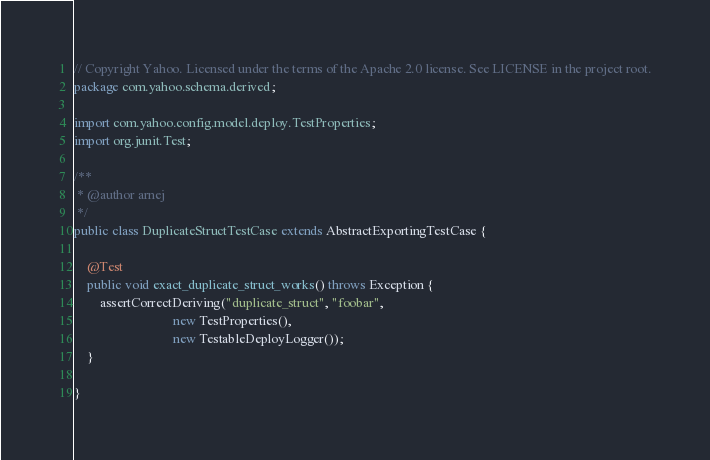<code> <loc_0><loc_0><loc_500><loc_500><_Java_>// Copyright Yahoo. Licensed under the terms of the Apache 2.0 license. See LICENSE in the project root.
package com.yahoo.schema.derived;

import com.yahoo.config.model.deploy.TestProperties;
import org.junit.Test;

/**
 * @author arnej
 */
public class DuplicateStructTestCase extends AbstractExportingTestCase {

    @Test
    public void exact_duplicate_struct_works() throws Exception {
        assertCorrectDeriving("duplicate_struct", "foobar",
                              new TestProperties(),
                              new TestableDeployLogger());
    }

}
</code> 